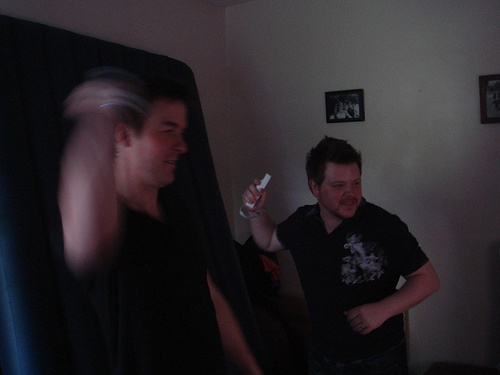Describe the objects in this image and their specific colors. I can see people in black, maroon, gray, and purple tones and remote in black and gray tones in this image. 